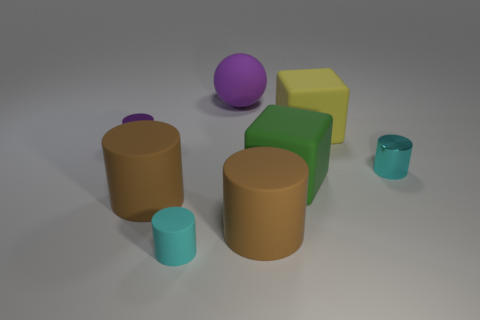There is a metallic cylinder that is the same color as the big rubber ball; what is its size?
Your answer should be compact. Small. What is the shape of the small thing that is made of the same material as the purple ball?
Provide a succinct answer. Cylinder. What number of rubber objects are either spheres or big brown cylinders?
Make the answer very short. 3. How many large matte cubes are behind the tiny metal thing that is to the right of the rubber object behind the large yellow block?
Give a very brief answer. 1. Do the rubber block that is in front of the cyan metal cylinder and the shiny thing that is in front of the tiny purple cylinder have the same size?
Provide a succinct answer. No. What material is the other thing that is the same shape as the big yellow rubber thing?
Provide a succinct answer. Rubber. How many tiny objects are either cylinders or yellow blocks?
Provide a succinct answer. 3. What material is the small purple object?
Your response must be concise. Metal. There is a thing that is right of the big green rubber block and in front of the large yellow matte block; what material is it made of?
Your response must be concise. Metal. There is a small matte cylinder; is it the same color as the small shiny cylinder that is on the left side of the tiny cyan metal thing?
Provide a succinct answer. No. 